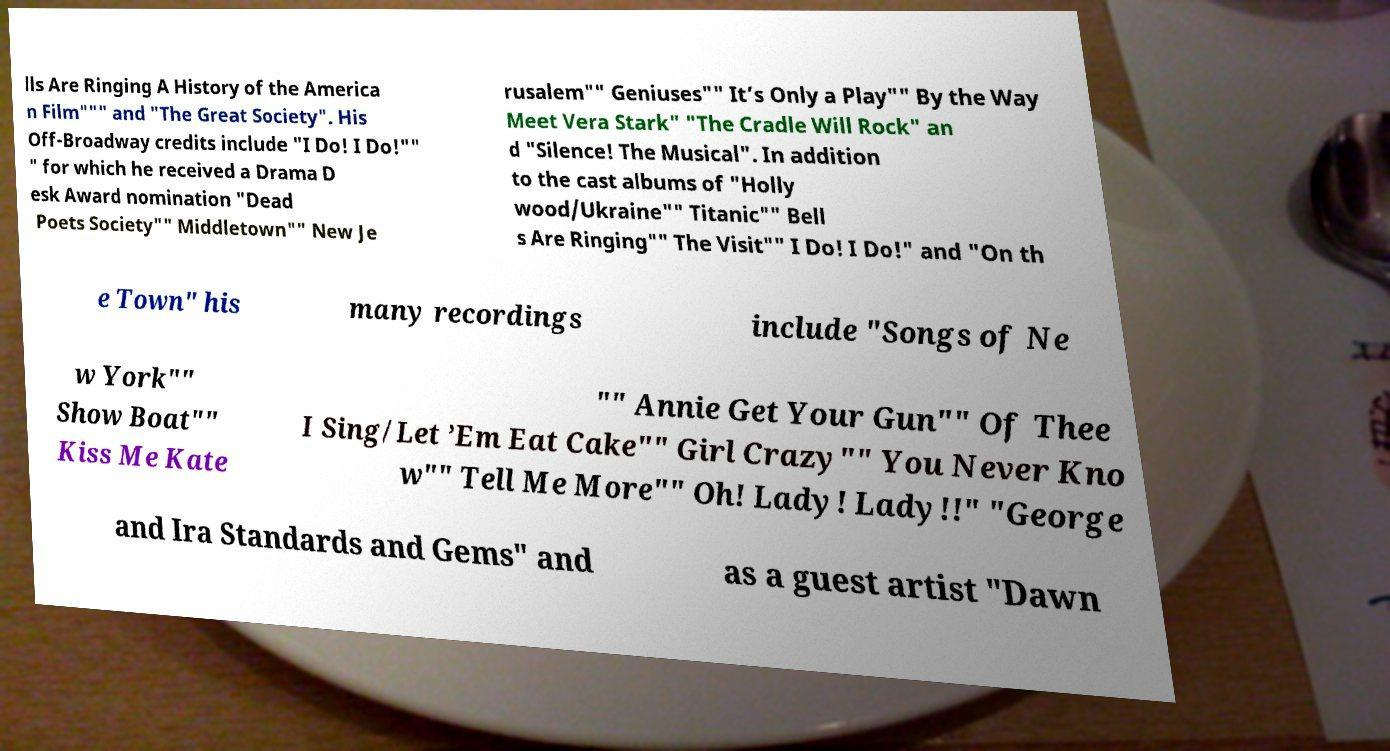Could you extract and type out the text from this image? lls Are Ringing A History of the America n Film""" and "The Great Society". His Off-Broadway credits include "I Do! I Do!"" " for which he received a Drama D esk Award nomination "Dead Poets Society"" Middletown"" New Je rusalem"" Geniuses"" It’s Only a Play"" By the Way Meet Vera Stark" "The Cradle Will Rock" an d "Silence! The Musical". In addition to the cast albums of "Holly wood/Ukraine"" Titanic"" Bell s Are Ringing"" The Visit"" I Do! I Do!" and "On th e Town" his many recordings include "Songs of Ne w York"" Show Boat"" Kiss Me Kate "" Annie Get Your Gun"" Of Thee I Sing/Let ’Em Eat Cake"" Girl Crazy"" You Never Kno w"" Tell Me More"" Oh! Lady! Lady!!" "George and Ira Standards and Gems" and as a guest artist "Dawn 